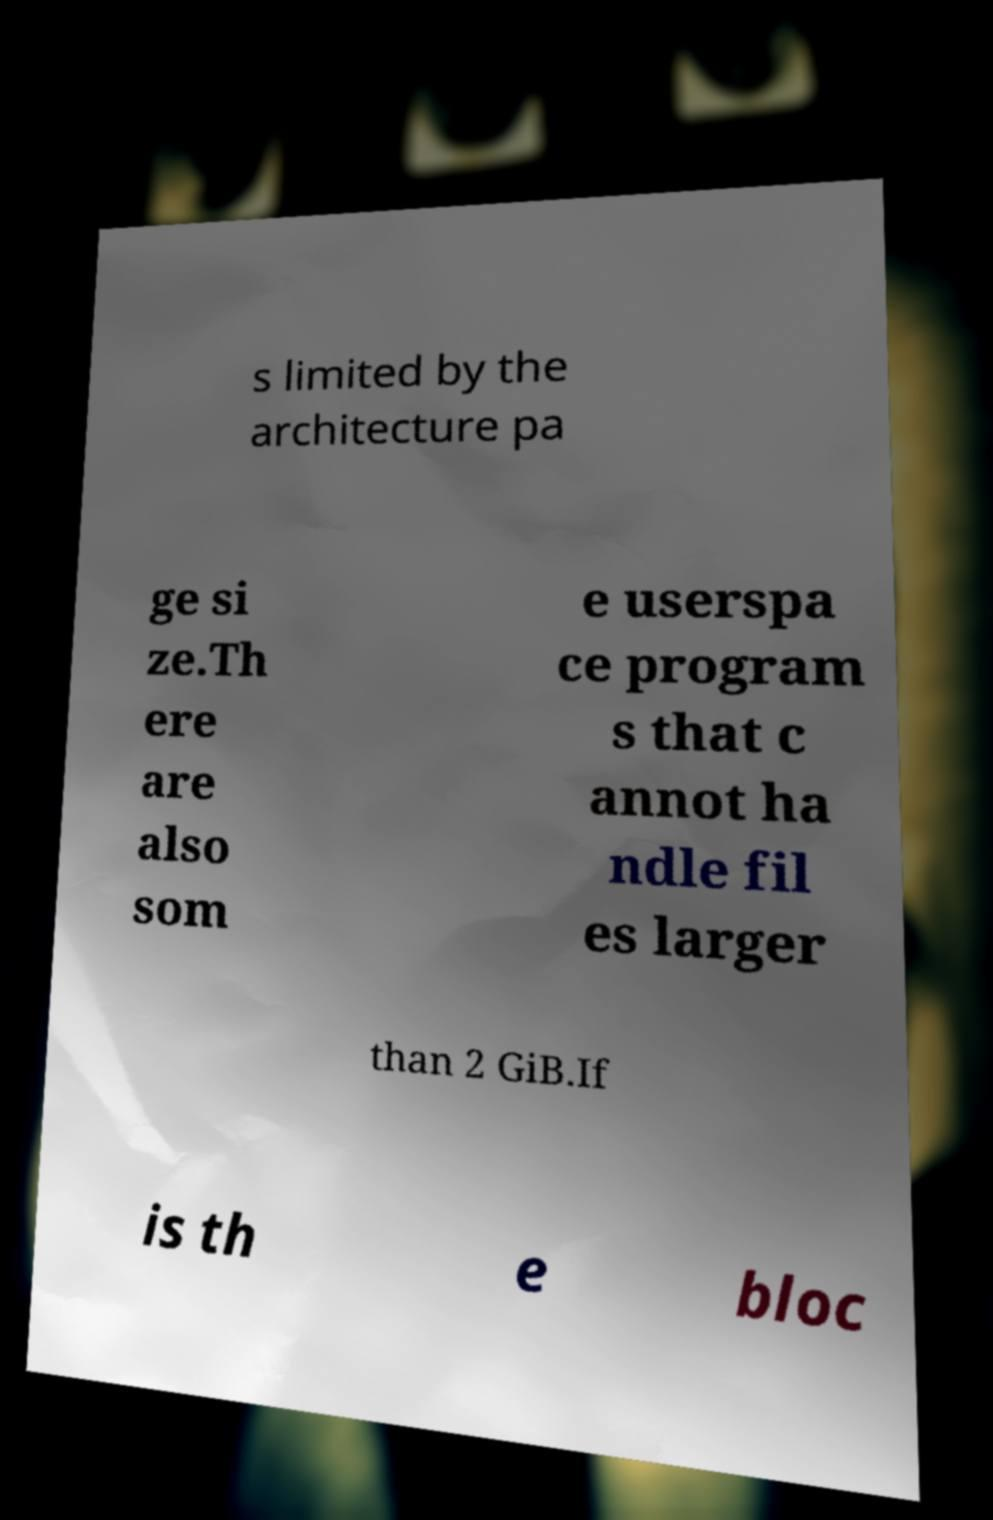Could you assist in decoding the text presented in this image and type it out clearly? s limited by the architecture pa ge si ze.Th ere are also som e userspa ce program s that c annot ha ndle fil es larger than 2 GiB.If is th e bloc 